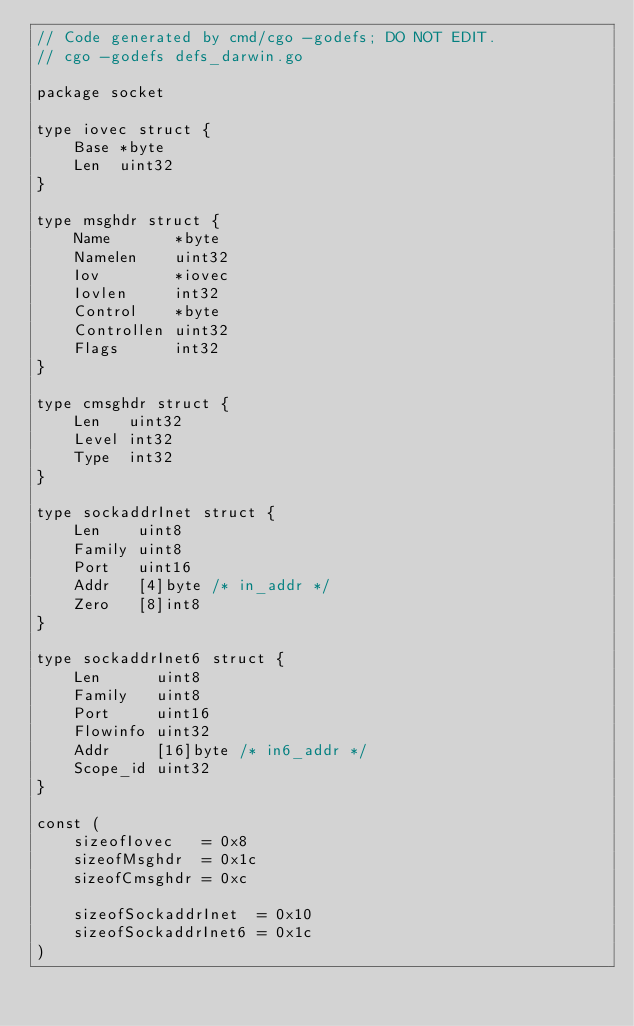Convert code to text. <code><loc_0><loc_0><loc_500><loc_500><_Go_>// Code generated by cmd/cgo -godefs; DO NOT EDIT.
// cgo -godefs defs_darwin.go

package socket

type iovec struct {
	Base *byte
	Len  uint32
}

type msghdr struct {
	Name       *byte
	Namelen    uint32
	Iov        *iovec
	Iovlen     int32
	Control    *byte
	Controllen uint32
	Flags      int32
}

type cmsghdr struct {
	Len   uint32
	Level int32
	Type  int32
}

type sockaddrInet struct {
	Len    uint8
	Family uint8
	Port   uint16
	Addr   [4]byte /* in_addr */
	Zero   [8]int8
}

type sockaddrInet6 struct {
	Len      uint8
	Family   uint8
	Port     uint16
	Flowinfo uint32
	Addr     [16]byte /* in6_addr */
	Scope_id uint32
}

const (
	sizeofIovec   = 0x8
	sizeofMsghdr  = 0x1c
	sizeofCmsghdr = 0xc

	sizeofSockaddrInet  = 0x10
	sizeofSockaddrInet6 = 0x1c
)
</code> 